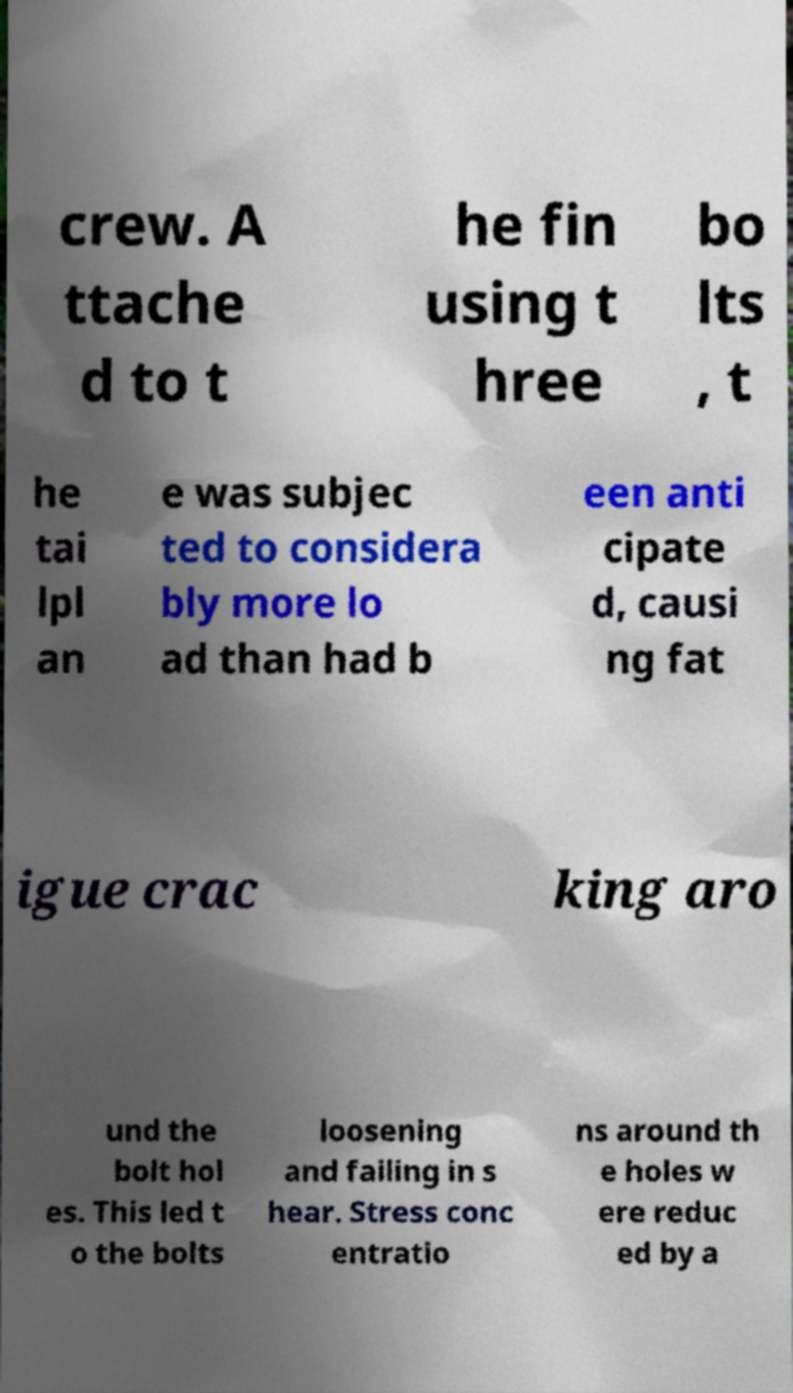Can you accurately transcribe the text from the provided image for me? crew. A ttache d to t he fin using t hree bo lts , t he tai lpl an e was subjec ted to considera bly more lo ad than had b een anti cipate d, causi ng fat igue crac king aro und the bolt hol es. This led t o the bolts loosening and failing in s hear. Stress conc entratio ns around th e holes w ere reduc ed by a 